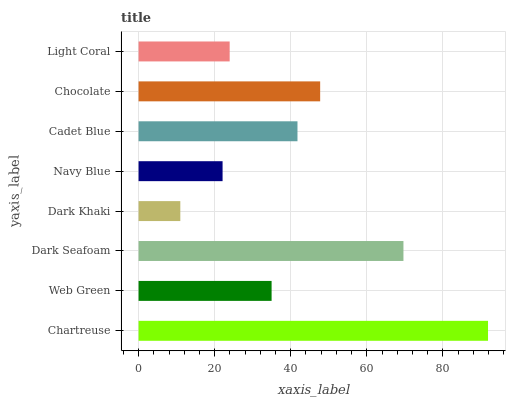Is Dark Khaki the minimum?
Answer yes or no. Yes. Is Chartreuse the maximum?
Answer yes or no. Yes. Is Web Green the minimum?
Answer yes or no. No. Is Web Green the maximum?
Answer yes or no. No. Is Chartreuse greater than Web Green?
Answer yes or no. Yes. Is Web Green less than Chartreuse?
Answer yes or no. Yes. Is Web Green greater than Chartreuse?
Answer yes or no. No. Is Chartreuse less than Web Green?
Answer yes or no. No. Is Cadet Blue the high median?
Answer yes or no. Yes. Is Web Green the low median?
Answer yes or no. Yes. Is Navy Blue the high median?
Answer yes or no. No. Is Chocolate the low median?
Answer yes or no. No. 